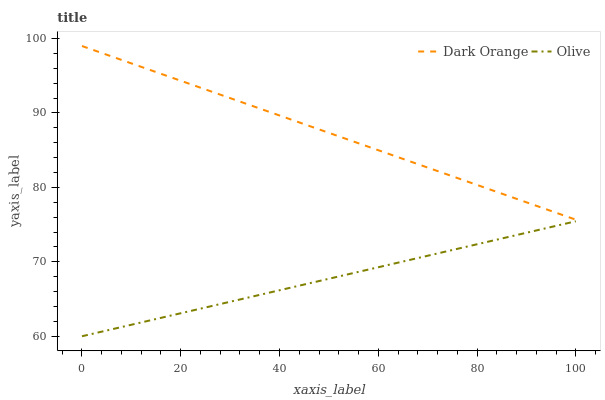Does Olive have the minimum area under the curve?
Answer yes or no. Yes. Does Dark Orange have the maximum area under the curve?
Answer yes or no. Yes. Does Dark Orange have the minimum area under the curve?
Answer yes or no. No. Is Dark Orange the smoothest?
Answer yes or no. Yes. Is Olive the roughest?
Answer yes or no. Yes. Is Dark Orange the roughest?
Answer yes or no. No. Does Dark Orange have the lowest value?
Answer yes or no. No. Does Dark Orange have the highest value?
Answer yes or no. Yes. Is Olive less than Dark Orange?
Answer yes or no. Yes. Is Dark Orange greater than Olive?
Answer yes or no. Yes. Does Olive intersect Dark Orange?
Answer yes or no. No. 